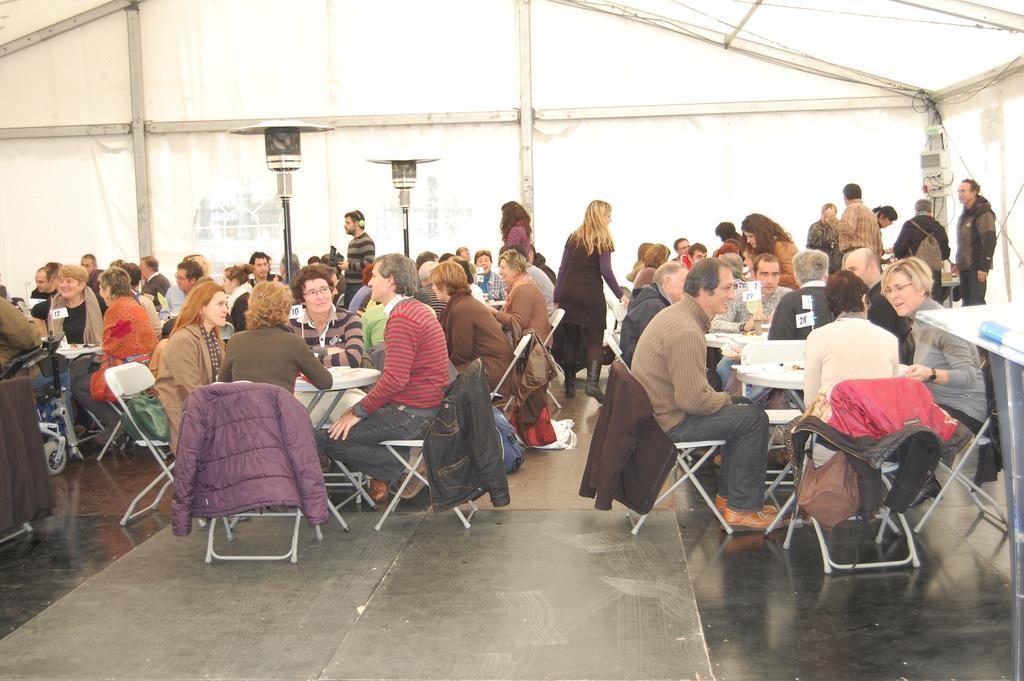Can you describe this image briefly? The picture looks like it is taken in a restaurant. In the background there is tent. On the right there is a table. There are tables, chairs and people seated all over. 